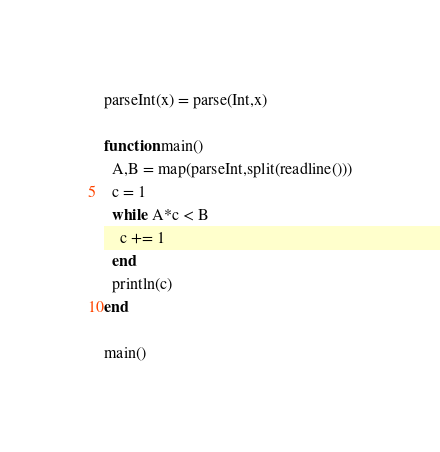Convert code to text. <code><loc_0><loc_0><loc_500><loc_500><_Julia_>parseInt(x) = parse(Int,x)

function main()
  A,B = map(parseInt,split(readline()))
  c = 1
  while A*c < B
    c += 1
  end
  println(c)
end

main()</code> 